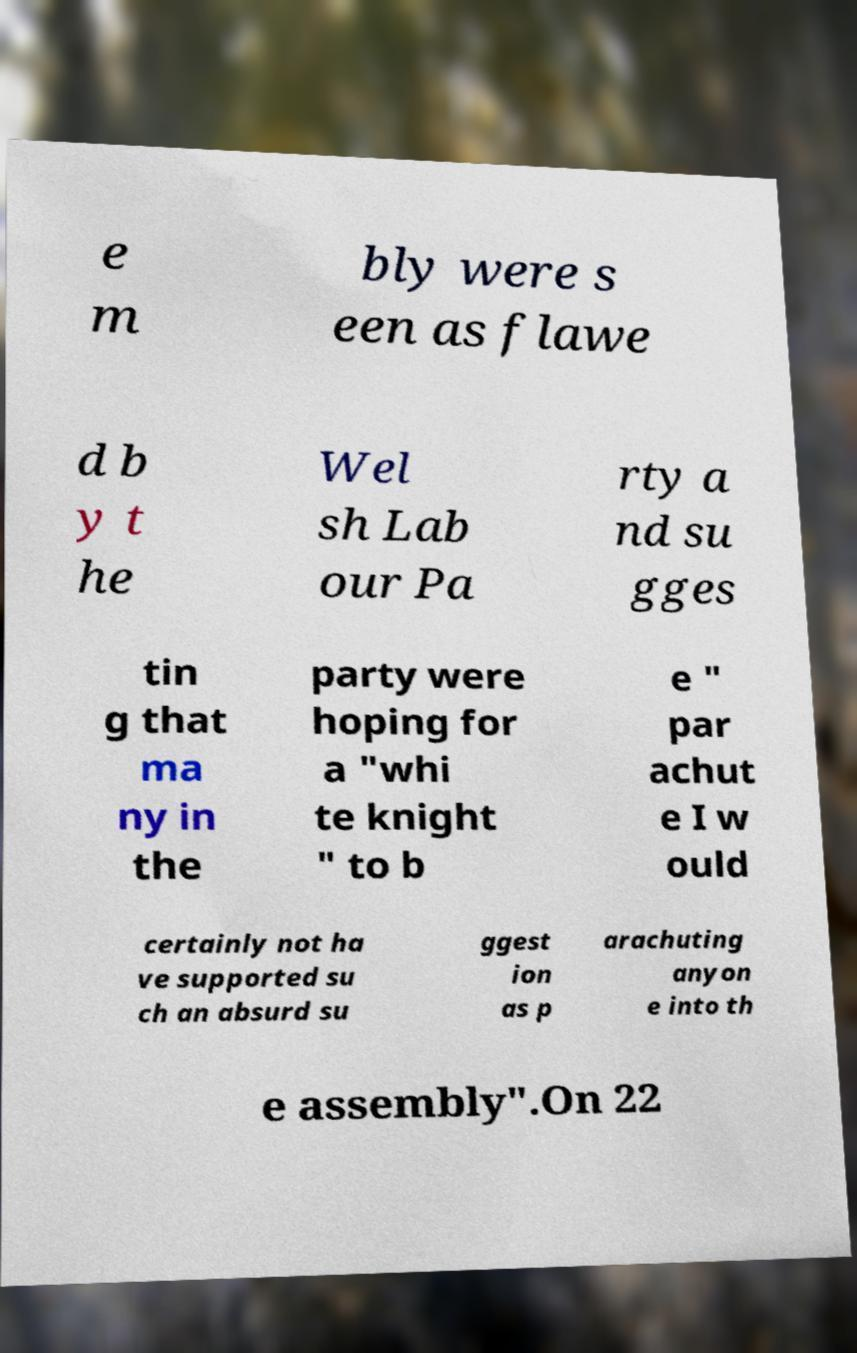What messages or text are displayed in this image? I need them in a readable, typed format. e m bly were s een as flawe d b y t he Wel sh Lab our Pa rty a nd su gges tin g that ma ny in the party were hoping for a "whi te knight " to b e " par achut e I w ould certainly not ha ve supported su ch an absurd su ggest ion as p arachuting anyon e into th e assembly".On 22 